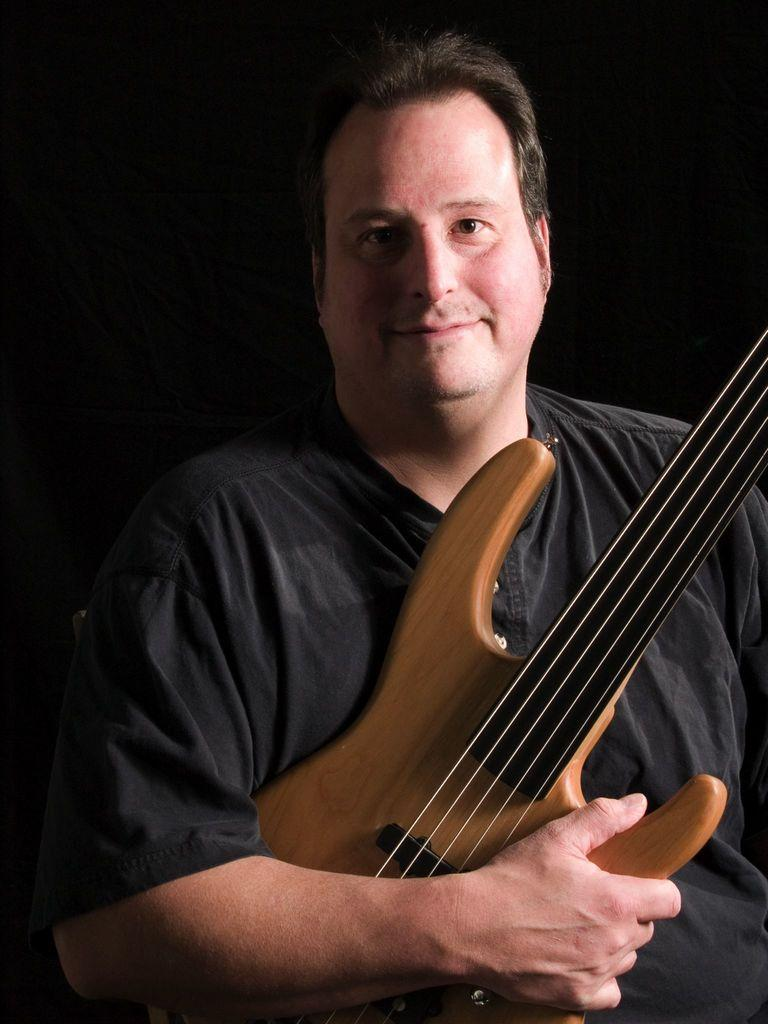What is the man in the image holding? The man is holding a guitar. What can be said about the guitar's appearance? The guitar is brown in color and has strings. What is the man wearing in the image? The man is wearing a black shirt. What is the color of the background in the image? The background of the image is black. What type of lamp is the man using to grip the guitar strings in the image? There is no lamp present in the image, and the man is not using any device to grip the guitar strings. 